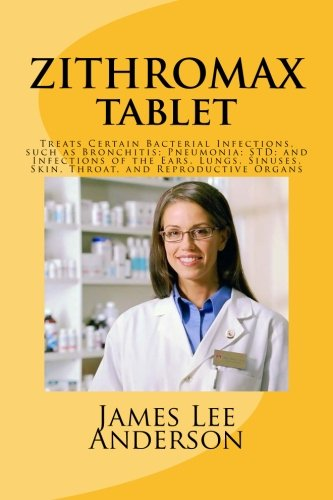Who is the author of this book?
Answer the question using a single word or phrase. James Lee Anderson What is the title of this book? ZITHROMAX Tablet: Treats Certain Bacterial Infections, such as Bronchitis; Pneumonia; STD; and Infections of the Ears, Lungs, Sinuses, Skin, Throat, and Reproductive Organs What is the genre of this book? Health, Fitness & Dieting Is this a fitness book? Yes Is this a digital technology book? No 